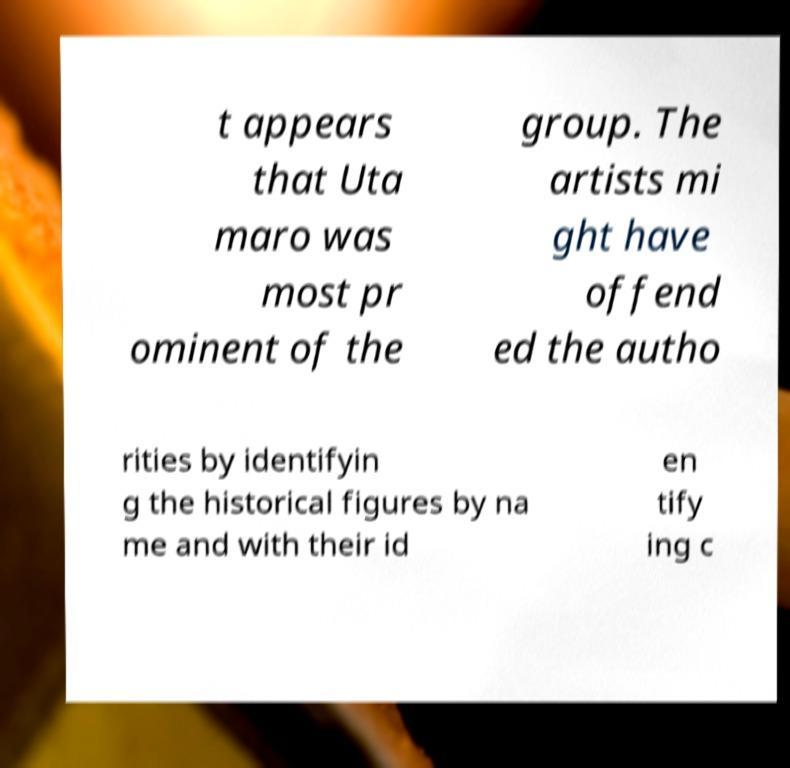Can you read and provide the text displayed in the image?This photo seems to have some interesting text. Can you extract and type it out for me? t appears that Uta maro was most pr ominent of the group. The artists mi ght have offend ed the autho rities by identifyin g the historical figures by na me and with their id en tify ing c 